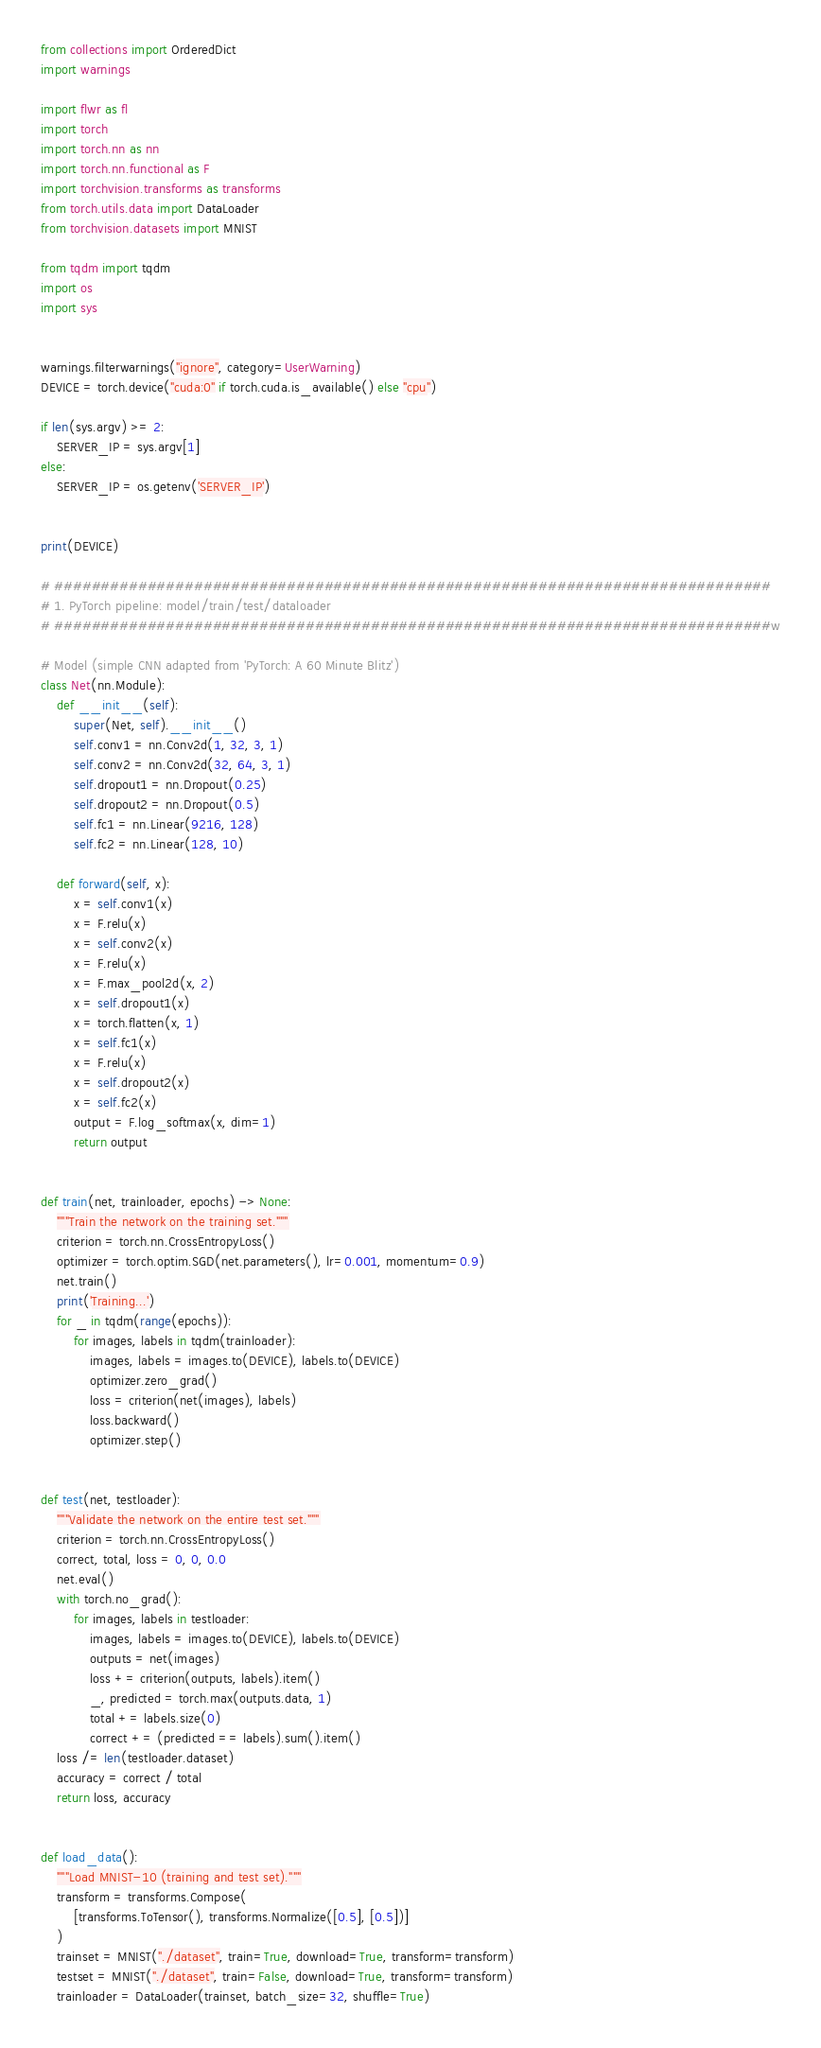Convert code to text. <code><loc_0><loc_0><loc_500><loc_500><_Python_>from collections import OrderedDict
import warnings

import flwr as fl
import torch
import torch.nn as nn
import torch.nn.functional as F
import torchvision.transforms as transforms
from torch.utils.data import DataLoader
from torchvision.datasets import MNIST

from tqdm import tqdm
import os
import sys


warnings.filterwarnings("ignore", category=UserWarning)
DEVICE = torch.device("cuda:0" if torch.cuda.is_available() else "cpu")

if len(sys.argv) >= 2:
    SERVER_IP = sys.argv[1]
else:
    SERVER_IP = os.getenv('SERVER_IP') 


print(DEVICE)

# #############################################################################
# 1. PyTorch pipeline: model/train/test/dataloader
# #############################################################################w

# Model (simple CNN adapted from 'PyTorch: A 60 Minute Blitz')
class Net(nn.Module):
    def __init__(self): 
        super(Net, self).__init__()
        self.conv1 = nn.Conv2d(1, 32, 3, 1)
        self.conv2 = nn.Conv2d(32, 64, 3, 1)
        self.dropout1 = nn.Dropout(0.25)
        self.dropout2 = nn.Dropout(0.5)
        self.fc1 = nn.Linear(9216, 128)
        self.fc2 = nn.Linear(128, 10)

    def forward(self, x):
        x = self.conv1(x)
        x = F.relu(x)
        x = self.conv2(x)
        x = F.relu(x)
        x = F.max_pool2d(x, 2)
        x = self.dropout1(x)
        x = torch.flatten(x, 1)
        x = self.fc1(x)
        x = F.relu(x)
        x = self.dropout2(x)
        x = self.fc2(x)
        output = F.log_softmax(x, dim=1)
        return output


def train(net, trainloader, epochs) -> None:
    """Train the network on the training set."""
    criterion = torch.nn.CrossEntropyLoss()
    optimizer = torch.optim.SGD(net.parameters(), lr=0.001, momentum=0.9)
    net.train()
    print('Training...')
    for _ in tqdm(range(epochs)):
        for images, labels in tqdm(trainloader):
            images, labels = images.to(DEVICE), labels.to(DEVICE)
            optimizer.zero_grad()
            loss = criterion(net(images), labels)
            loss.backward()
            optimizer.step()


def test(net, testloader):
    """Validate the network on the entire test set."""
    criterion = torch.nn.CrossEntropyLoss()
    correct, total, loss = 0, 0, 0.0
    net.eval()
    with torch.no_grad():
        for images, labels in testloader:
            images, labels = images.to(DEVICE), labels.to(DEVICE)
            outputs = net(images)
            loss += criterion(outputs, labels).item()
            _, predicted = torch.max(outputs.data, 1)
            total += labels.size(0)
            correct += (predicted == labels).sum().item()
    loss /= len(testloader.dataset)
    accuracy = correct / total
    return loss, accuracy


def load_data():
    """Load MNIST-10 (training and test set)."""
    transform = transforms.Compose(
        [transforms.ToTensor(), transforms.Normalize([0.5], [0.5])]
    )
    trainset = MNIST("./dataset", train=True, download=True, transform=transform)
    testset = MNIST("./dataset", train=False, download=True, transform=transform)
    trainloader = DataLoader(trainset, batch_size=32, shuffle=True)</code> 